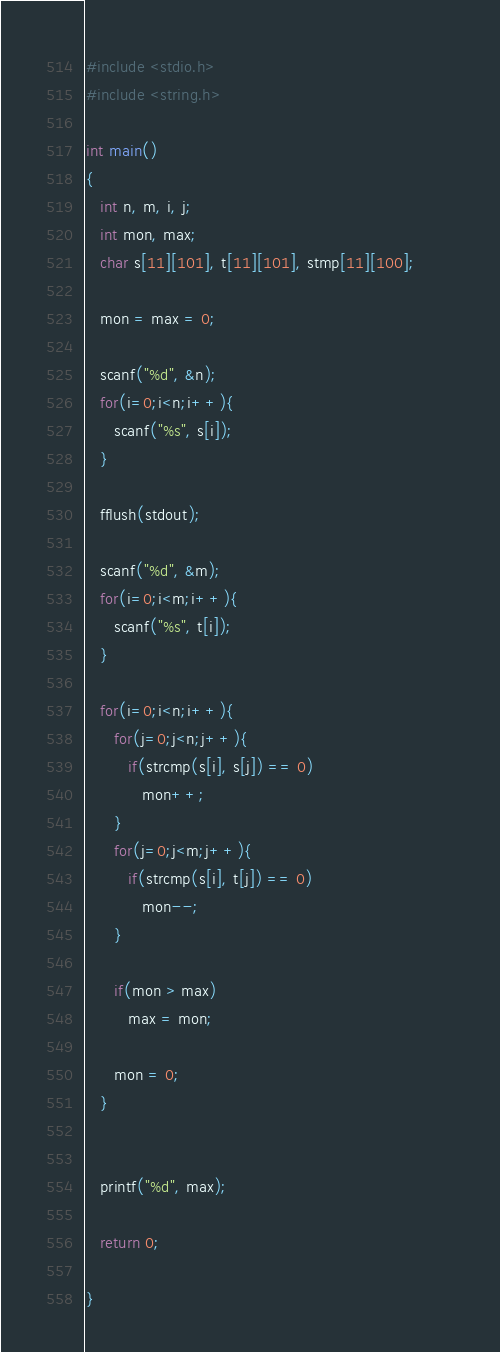Convert code to text. <code><loc_0><loc_0><loc_500><loc_500><_C_>#include <stdio.h>                                                   
#include <string.h>

int main()
{   
   int n, m, i, j;
   int mon, max;
   char s[11][101], t[11][101], stmp[11][100];

   mon = max = 0;

   scanf("%d", &n);
   for(i=0;i<n;i++){
      scanf("%s", s[i]);
   }

   fflush(stdout);

   scanf("%d", &m);
   for(i=0;i<m;i++){
      scanf("%s", t[i]);
   }

   for(i=0;i<n;i++){
      for(j=0;j<n;j++){
         if(strcmp(s[i], s[j]) == 0)
            mon++;
      }
      for(j=0;j<m;j++){
         if(strcmp(s[i], t[j]) == 0)
            mon--;
      }

      if(mon > max)
         max = mon;

      mon = 0;
   }


   printf("%d", max);

   return 0;

}</code> 